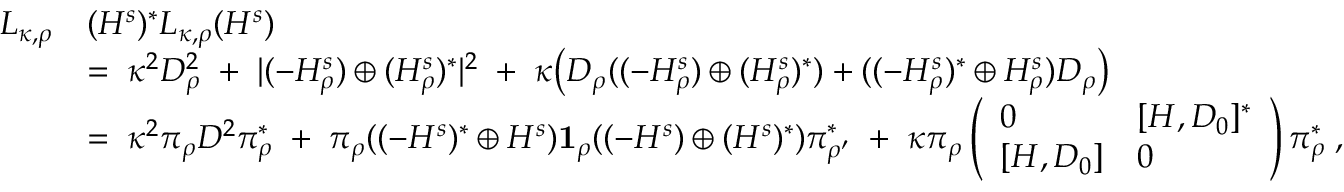Convert formula to latex. <formula><loc_0><loc_0><loc_500><loc_500>\begin{array} { r l } { L _ { \kappa , \rho } } & { ( H ^ { s } ) ^ { * } L _ { \kappa , \rho } ( H ^ { s } ) } \\ & { = \, \kappa ^ { 2 } D _ { \rho } ^ { 2 } \, + \, | ( - H _ { \rho } ^ { s } ) \oplus ( H _ { \rho } ^ { s } ) ^ { * } | ^ { 2 } \, + \, \kappa \left ( D _ { \rho } ( ( - H _ { \rho } ^ { s } ) \oplus ( H _ { \rho } ^ { s } ) ^ { * } ) + ( ( - H _ { \rho } ^ { s } ) ^ { * } \oplus H _ { \rho } ^ { s } ) D _ { \rho } \right ) } \\ & { = \, \kappa ^ { 2 } \pi _ { \rho } D ^ { 2 } \pi _ { \rho } ^ { * } \, + \, \pi _ { \rho } ( ( - H ^ { s } ) ^ { * } \oplus H ^ { s } ) { 1 } _ { \rho } ( ( - H ^ { s } ) \oplus ( H ^ { s } ) ^ { * } ) \pi _ { \rho ^ { \prime } } ^ { * } \, + \, \kappa \pi _ { \rho } \left ( \begin{array} { l l } { 0 } & { [ H , D _ { 0 } ] ^ { * } } \\ { [ H , D _ { 0 } ] } & { 0 } \end{array} \right ) \pi _ { \rho } ^ { * } \, , } \end{array}</formula> 